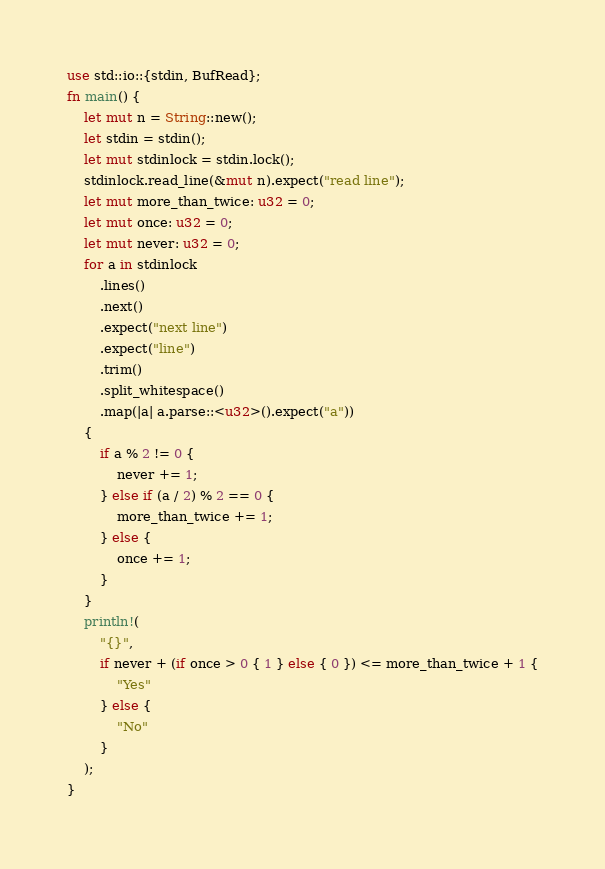Convert code to text. <code><loc_0><loc_0><loc_500><loc_500><_Rust_>use std::io::{stdin, BufRead};
fn main() {
    let mut n = String::new();
    let stdin = stdin();
    let mut stdinlock = stdin.lock();
    stdinlock.read_line(&mut n).expect("read line");
    let mut more_than_twice: u32 = 0;
    let mut once: u32 = 0;
    let mut never: u32 = 0;
    for a in stdinlock
        .lines()
        .next()
        .expect("next line")
        .expect("line")
        .trim()
        .split_whitespace()
        .map(|a| a.parse::<u32>().expect("a"))
    {
        if a % 2 != 0 {
            never += 1;
        } else if (a / 2) % 2 == 0 {
            more_than_twice += 1;
        } else {
            once += 1;
        }
    }
    println!(
        "{}",
        if never + (if once > 0 { 1 } else { 0 }) <= more_than_twice + 1 {
            "Yes"
        } else {
            "No"
        }
    );
}
</code> 